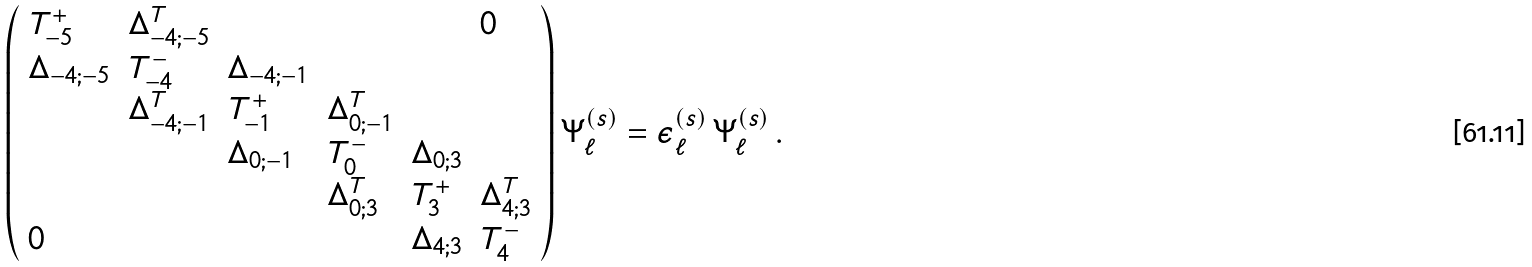Convert formula to latex. <formula><loc_0><loc_0><loc_500><loc_500>\left ( \begin{array} { l l l l l l } T _ { - 5 } ^ { + } & \Delta _ { - 4 ; - 5 } ^ { T } & & & & 0 \\ \Delta _ { - 4 ; - 5 } & T _ { - 4 } ^ { - } & \Delta _ { - 4 ; - 1 } & & & \\ & \Delta _ { - 4 ; - 1 } ^ { T } & T _ { - 1 } ^ { + } & \Delta _ { 0 ; - 1 } ^ { T } & & \\ & & \Delta _ { 0 ; - 1 } & T _ { 0 } ^ { - } & \Delta _ { 0 ; 3 } & \\ & & & \Delta _ { 0 ; 3 } ^ { T } & T _ { 3 } ^ { + } & \Delta _ { 4 ; 3 } ^ { T } \\ 0 & & & & \Delta _ { 4 ; 3 } & T _ { 4 } ^ { - } \\ \end{array} \right ) \Psi _ { \ell } ^ { ( s ) } = \epsilon _ { \ell } ^ { ( s ) } \, \Psi _ { \ell } ^ { ( s ) } \, .</formula> 